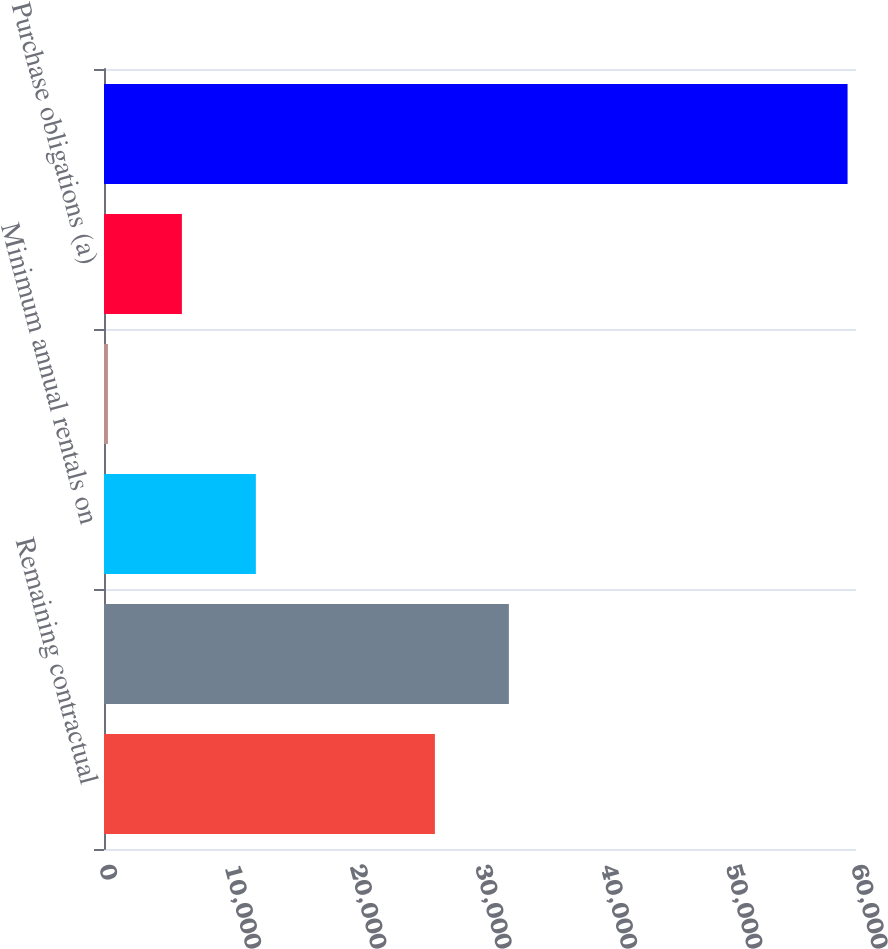<chart> <loc_0><loc_0><loc_500><loc_500><bar_chart><fcel>Remaining contractual<fcel>Borrowed funds<fcel>Minimum annual rentals on<fcel>Nonqualified pension and<fcel>Purchase obligations (a)<fcel>Total contractual cash<nl><fcel>26402<fcel>32303.3<fcel>12116.6<fcel>314<fcel>6215.3<fcel>59327<nl></chart> 